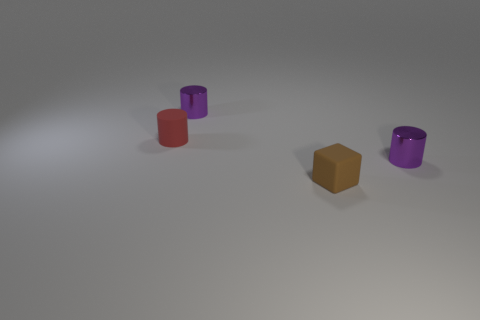How many purple cylinders must be subtracted to get 1 purple cylinders? 1 Subtract all purple shiny cylinders. How many cylinders are left? 1 Subtract all purple cylinders. How many cylinders are left? 1 Subtract 1 blocks. How many blocks are left? 0 Subtract all blocks. How many objects are left? 3 Subtract all yellow cylinders. Subtract all blue balls. How many cylinders are left? 3 Subtract all purple blocks. How many yellow cylinders are left? 0 Subtract all small brown cubes. Subtract all large gray metallic things. How many objects are left? 3 Add 3 red cylinders. How many red cylinders are left? 4 Add 1 brown rubber cubes. How many brown rubber cubes exist? 2 